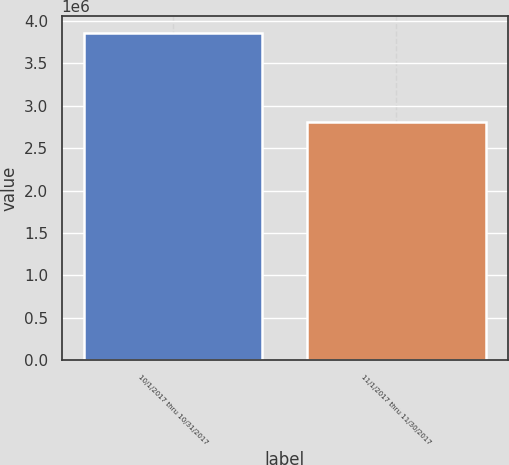Convert chart. <chart><loc_0><loc_0><loc_500><loc_500><bar_chart><fcel>10/1/2017 thru 10/31/2017<fcel>11/1/2017 thru 11/30/2017<nl><fcel>3.86089e+06<fcel>2.80617e+06<nl></chart> 